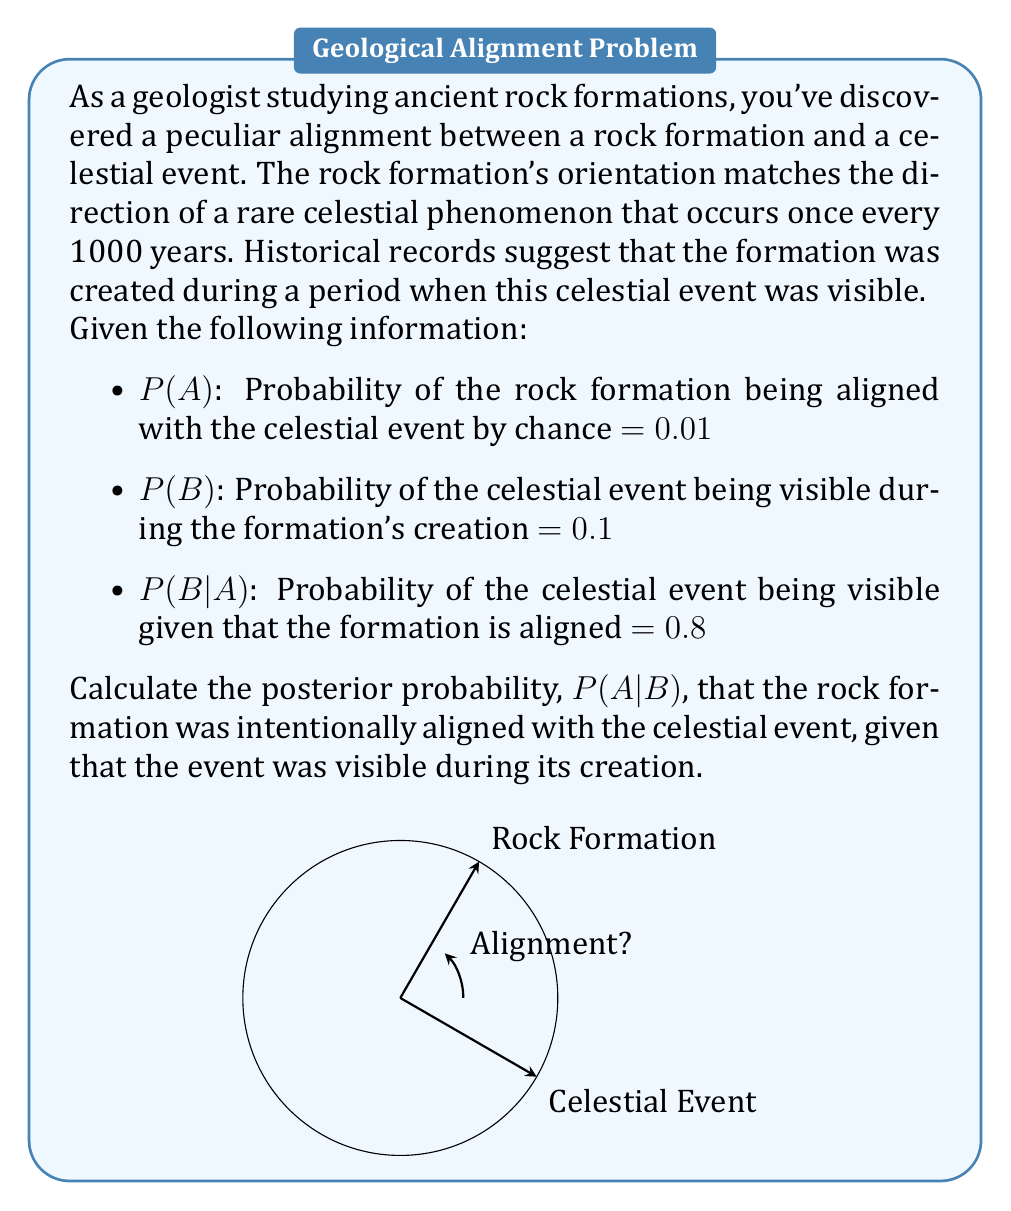Provide a solution to this math problem. To solve this problem, we'll use Bayes' Theorem:

$$P(A|B) = \frac{P(B|A) \cdot P(A)}{P(B)}$$

We're given:
- P(A) = 0.01 (prior probability of alignment)
- P(B) = 0.1 (probability of event visibility)
- P(B|A) = 0.8 (likelihood of event visibility given alignment)

Step 1: Calculate P(B) using the law of total probability:
$$P(B) = P(B|A) \cdot P(A) + P(B|\text{not }A) \cdot P(\text{not }A)$$

We know P(B|A) and P(A), but we need to calculate P(B|not A):
$$P(B|\text{not }A) = \frac{P(B) - P(B|A) \cdot P(A)}{P(\text{not }A)}$$
$$= \frac{0.1 - 0.8 \cdot 0.01}{0.99} = 0.0929$$

Step 2: Apply Bayes' Theorem:
$$P(A|B) = \frac{0.8 \cdot 0.01}{0.1} = 0.08$$

Therefore, the posterior probability that the rock formation was intentionally aligned with the celestial event, given that the event was visible during its creation, is 0.08 or 8%.
Answer: 0.08 